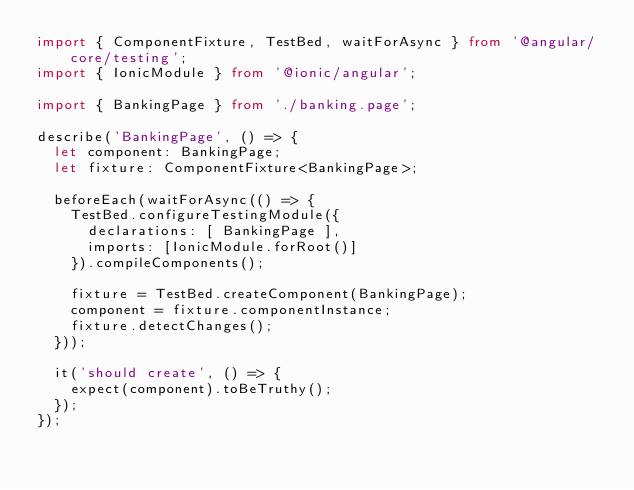Convert code to text. <code><loc_0><loc_0><loc_500><loc_500><_TypeScript_>import { ComponentFixture, TestBed, waitForAsync } from '@angular/core/testing';
import { IonicModule } from '@ionic/angular';

import { BankingPage } from './banking.page';

describe('BankingPage', () => {
  let component: BankingPage;
  let fixture: ComponentFixture<BankingPage>;

  beforeEach(waitForAsync(() => {
    TestBed.configureTestingModule({
      declarations: [ BankingPage ],
      imports: [IonicModule.forRoot()]
    }).compileComponents();

    fixture = TestBed.createComponent(BankingPage);
    component = fixture.componentInstance;
    fixture.detectChanges();
  }));

  it('should create', () => {
    expect(component).toBeTruthy();
  });
});
</code> 